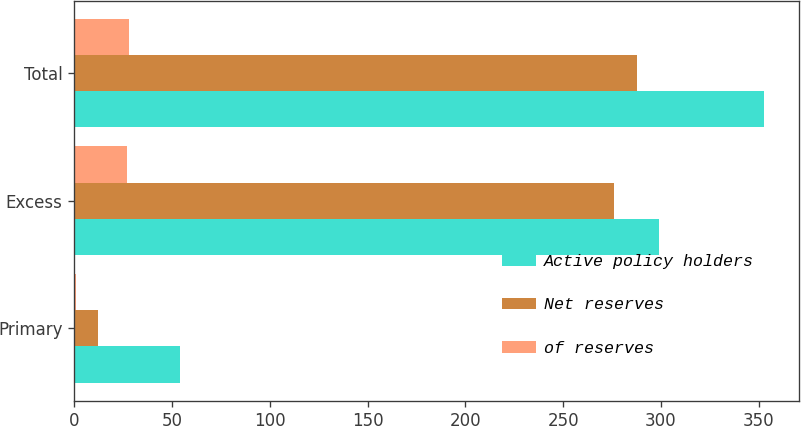Convert chart to OTSL. <chart><loc_0><loc_0><loc_500><loc_500><stacked_bar_chart><ecel><fcel>Primary<fcel>Excess<fcel>Total<nl><fcel>Active policy holders<fcel>54<fcel>299<fcel>353<nl><fcel>Net reserves<fcel>12<fcel>276<fcel>288<nl><fcel>of reserves<fcel>1<fcel>27<fcel>28<nl></chart> 